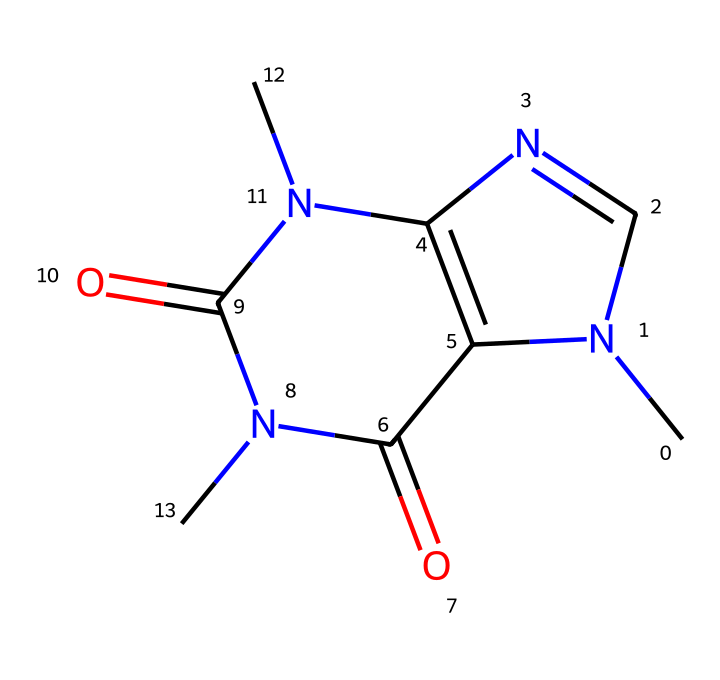What is the name of this chemical? The provided SMILES representation corresponds to caffeine, which is widely recognized for its stimulating effects. The molecular structure reveals its characteristic arrangement of atoms that define it as caffeine.
Answer: caffeine How many nitrogen atoms are present in the molecule? By examining the SMILES and interpreting the structure, there are four nitrogen atoms indicated in the molecular composition. Each nitrogen is represented by "N" in the SMILES notation.
Answer: four What is the molecular formula of this chemical? The molecular formula can be derived by counting each type of atom in the structure. In the case of caffeine, the chemical formula is C8H10N4O2, reflecting its composition of carbon, hydrogen, nitrogen, and oxygen.
Answer: C8H10N4O2 How many rings are present in the structure? The structure reveals that caffeine contains two fused rings as indicated by the cyclic portions of the structure. This can be counted by identifying the cycles formed by the atoms in the SMILES representation.
Answer: two What role does caffeine play in workplace productivity? Caffeine is known to enhance alertness and concentration, making it a popular choice for improving productivity in workplace settings. This is due to its stimulating effects on the central nervous system.
Answer: stimulant How does the presence of nitrogen contribute to the properties of caffeine? The nitrogen atoms in caffeine contribute to its classification as an alkaloid, which typically has distinct biological activities, including the ability to affect the central nervous system and influence productivity levels.
Answer: alkaloid What type of solvent is caffeine commonly associated with? Caffeine is most commonly associated with aqueous solutions, as it readily dissolves in water, and is often present in beverages like coffee and tea, acting as a solute in these solvents.
Answer: aqueous 